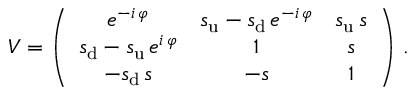Convert formula to latex. <formula><loc_0><loc_0><loc_500><loc_500>V = \left ( \begin{array} { c c c } { { e ^ { - i \, \varphi } } } & { { s _ { u } - s _ { d } \, e ^ { - i \, \varphi } } } & { { s _ { u } \, s } } \\ { { s _ { d } - s _ { u } \, e ^ { i \, \varphi } } } & { 1 } & { s } \\ { { - s _ { d } \, s } } & { - s } & { 1 } \end{array} \right ) \, .</formula> 